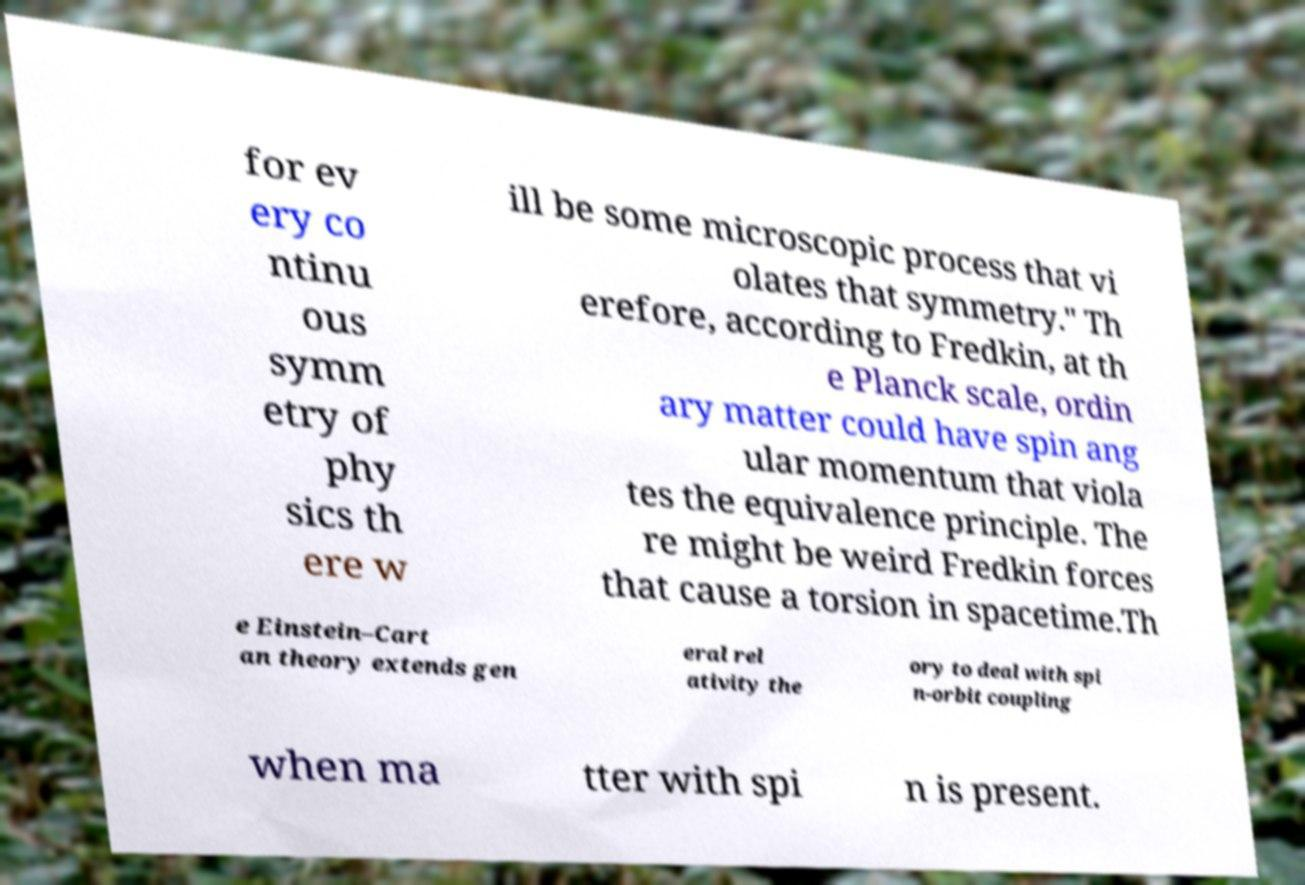Can you accurately transcribe the text from the provided image for me? for ev ery co ntinu ous symm etry of phy sics th ere w ill be some microscopic process that vi olates that symmetry." Th erefore, according to Fredkin, at th e Planck scale, ordin ary matter could have spin ang ular momentum that viola tes the equivalence principle. The re might be weird Fredkin forces that cause a torsion in spacetime.Th e Einstein–Cart an theory extends gen eral rel ativity the ory to deal with spi n-orbit coupling when ma tter with spi n is present. 